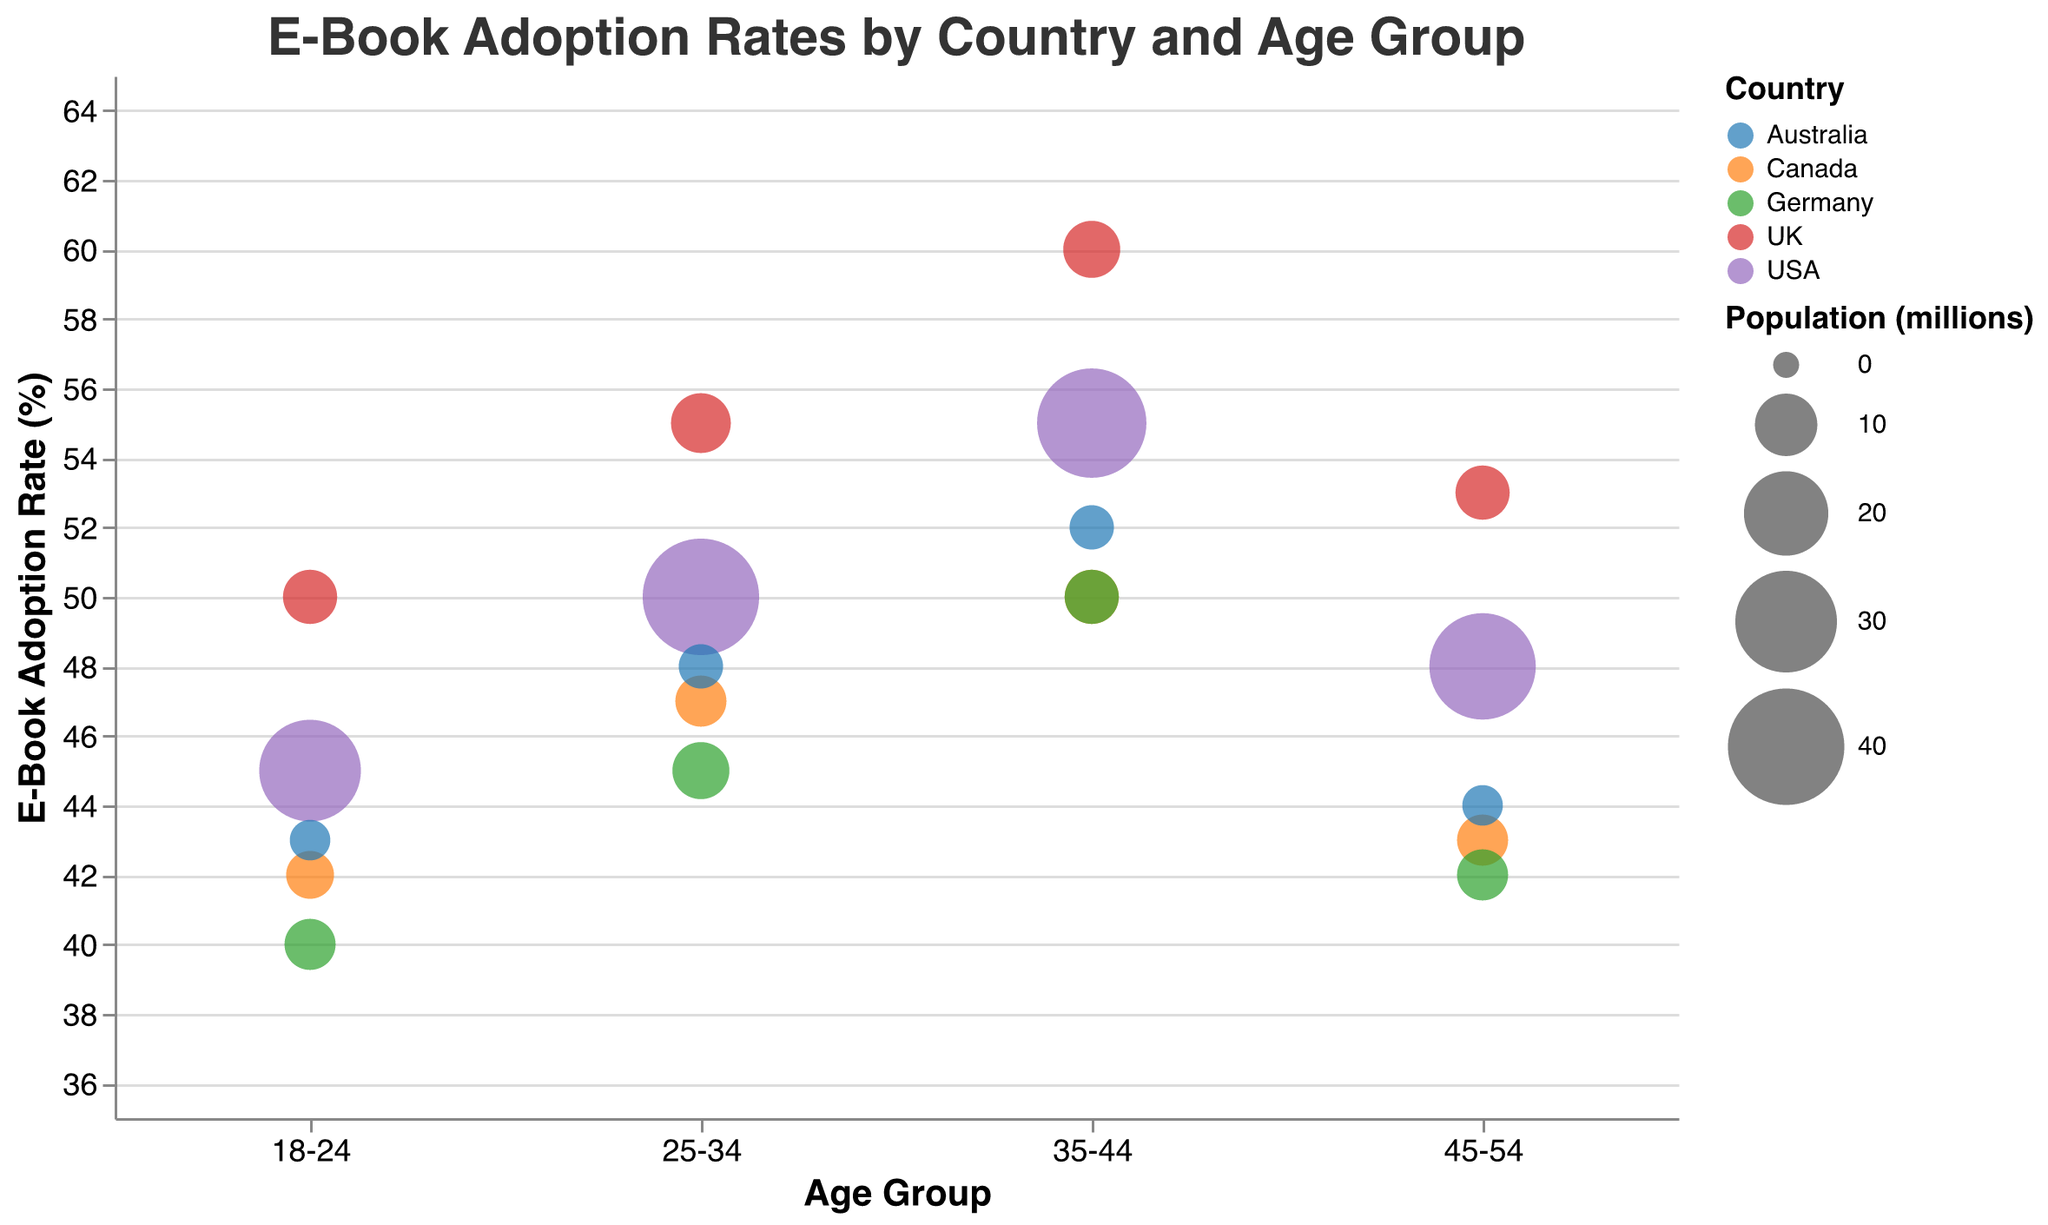What is the title of the chart? The title is displayed at the top of the chart and in larger bold text.
Answer: E-Book Adoption Rates by Country and Age Group What is the E-Book Adoption Rate (%) for the UK age group 35-44? Locate the bubble that corresponds to the UK and age group 35-44 on the x-axis, then check its y-axis value.
Answer: 60% Which country has the highest E-Book Adoption Rate (%) for age group 18-24? Compare the y-axis values for the bubbles corresponding to the age group 18-24 for all countries.
Answer: UK What is the difference in E-Book Adoption Rate (%) between the USA and Canada for the age group 25-34? Locate the bubbles for the USA and Canada for the age group 25-34 and subtract Canada's rate from the USA's rate.
Answer: 3% How many countries have their highest E-Book Adoption Rate (%) in the age group 35-44? Identify the highest adoption rate bubble for each country and count how many of these bubbles are in the 35-44 age group.
Answer: 3 Which age group has the lowest E-Book Adoption Rate in Germany? Identify the smallest y-axis value for Germany among all the age groups.
Answer: 18-24 What is the average E-Book Adoption Rate (%) across all age groups in Australia? Add the adoption rates for Australia across all age groups and divide by the number of age groups.
Answer: 46.75% Between USA and UK, which country has a higher E-Book Adoption Rate (%) for age group 45-54? Compare the y-axis values for the USA and UK for the age group 45-54.
Answer: UK Which bubble represents the largest population? Identify the bubble with the largest size (area) on the chart, which represents the population.
Answer: USA 25-34 Do any countries have the same E-Book Adoption Rate (%) for any age group? Look for bubbles that have the same y-axis value and are from different countries.
Answer: Yes, USA and Germany 35-44 